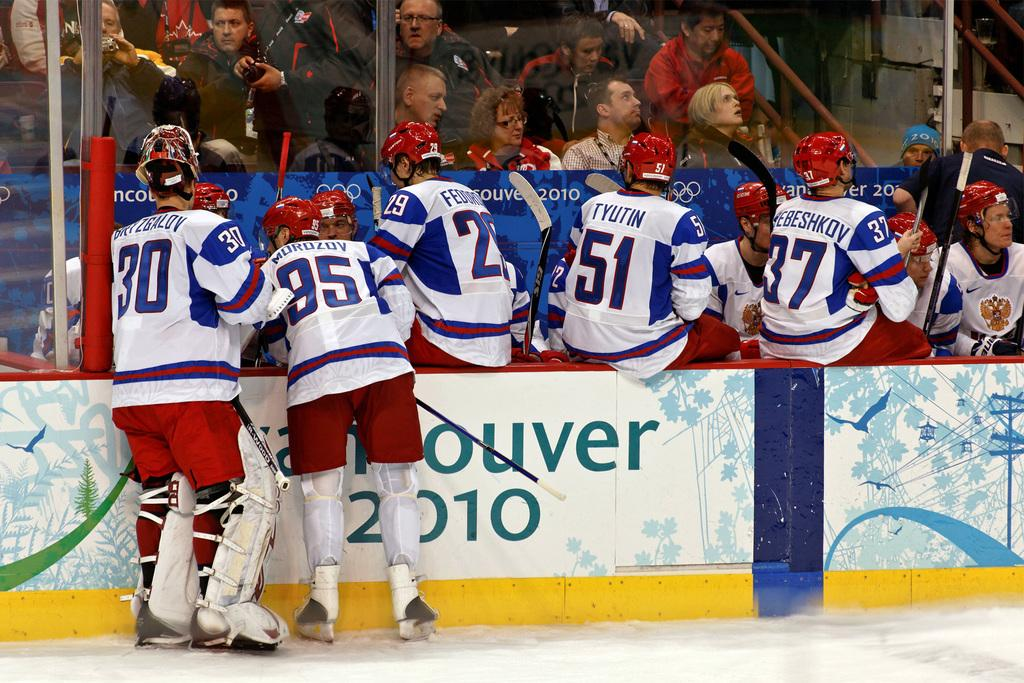<image>
Describe the image concisely. many players on the ice with one that has the number 30 on 